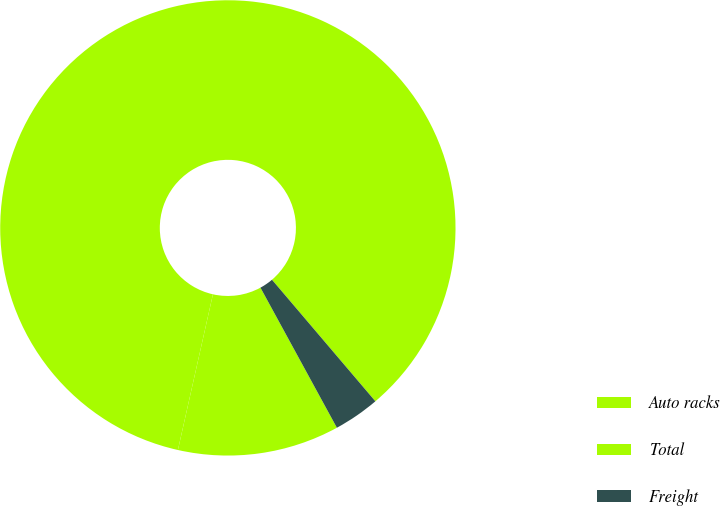Convert chart. <chart><loc_0><loc_0><loc_500><loc_500><pie_chart><fcel>Auto racks<fcel>Total<fcel>Freight<nl><fcel>11.47%<fcel>85.26%<fcel>3.27%<nl></chart> 